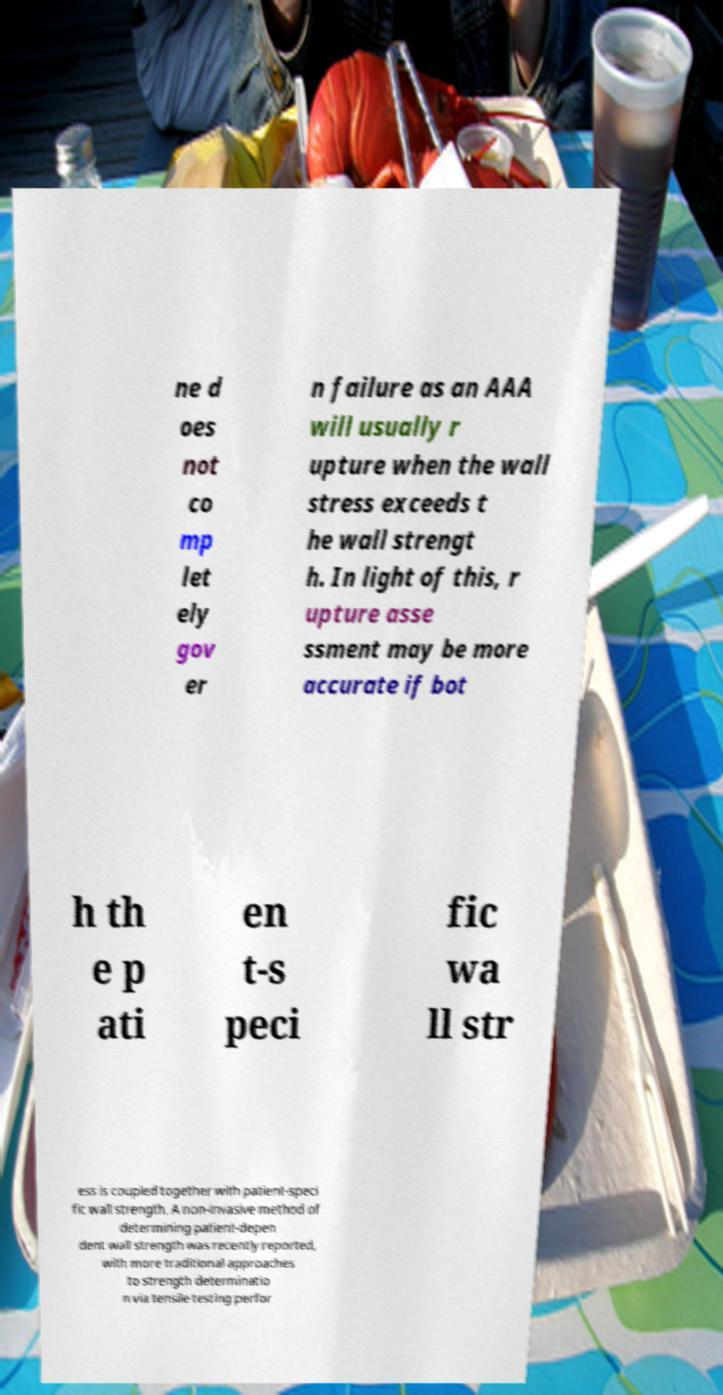Please read and relay the text visible in this image. What does it say? ne d oes not co mp let ely gov er n failure as an AAA will usually r upture when the wall stress exceeds t he wall strengt h. In light of this, r upture asse ssment may be more accurate if bot h th e p ati en t-s peci fic wa ll str ess is coupled together with patient-speci fic wall strength. A non-invasive method of determining patient-depen dent wall strength was recently reported, with more traditional approaches to strength determinatio n via tensile testing perfor 